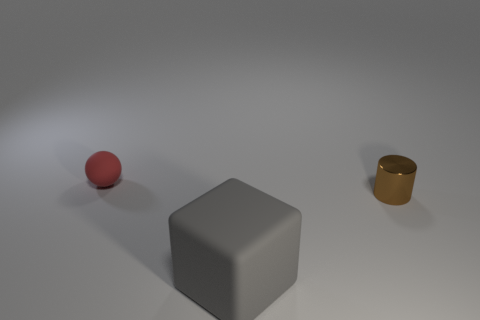Add 2 small purple metal cylinders. How many objects exist? 5 Subtract all cylinders. How many objects are left? 2 Add 3 red matte things. How many red matte things exist? 4 Subtract 0 cyan balls. How many objects are left? 3 Subtract all big gray things. Subtract all brown things. How many objects are left? 1 Add 2 tiny matte balls. How many tiny matte balls are left? 3 